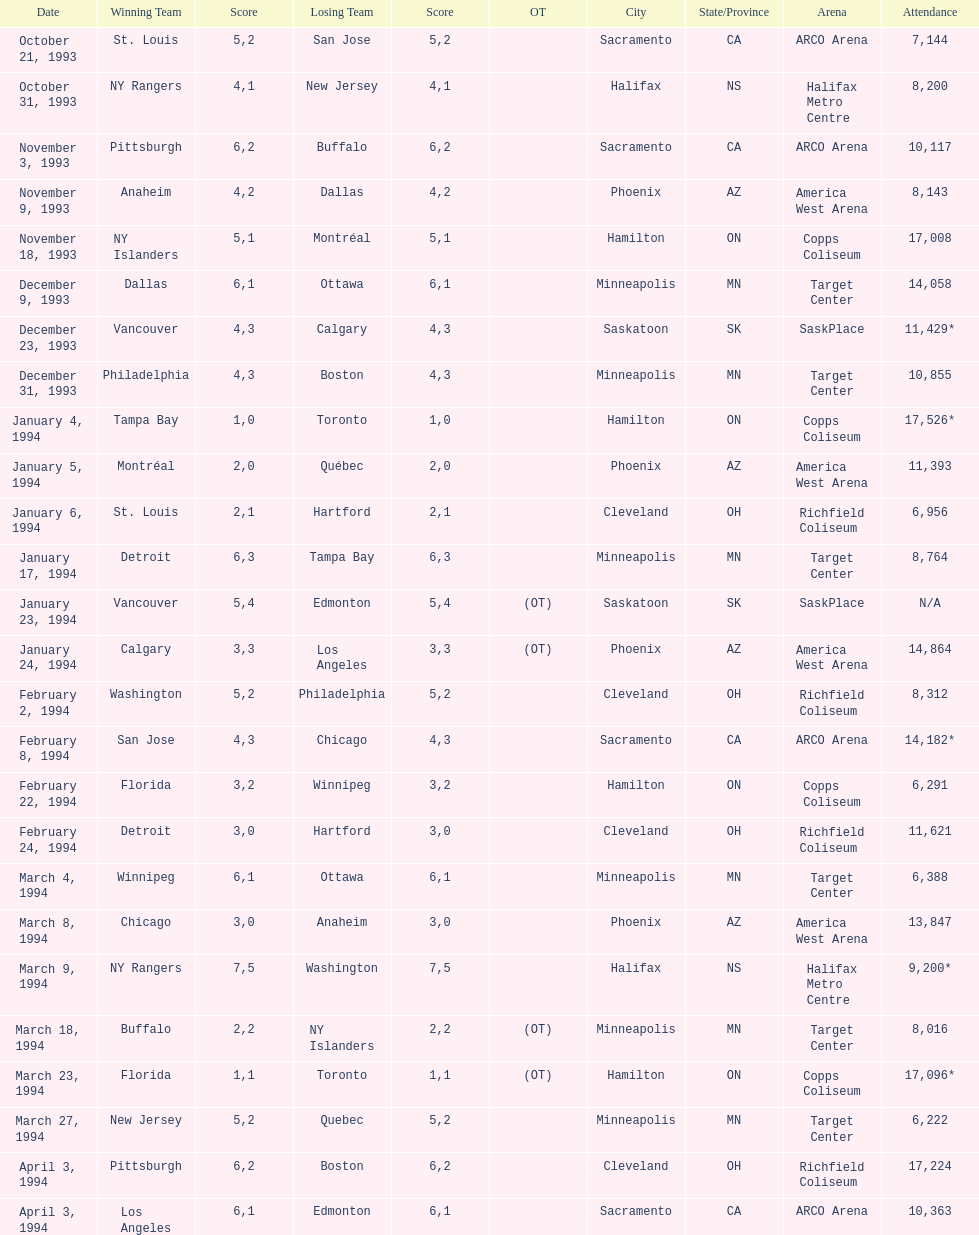Which event had higher attendance, january 24, 1994, or december 23, 1993? January 4, 1994. Parse the full table. {'header': ['Date', 'Winning Team', 'Score', 'Losing Team', 'Score', 'OT', 'City', 'State/Province', 'Arena', 'Attendance'], 'rows': [['October 21, 1993', 'St. Louis', '5', 'San Jose', '2', '', 'Sacramento', 'CA', 'ARCO Arena', '7,144'], ['October 31, 1993', 'NY Rangers', '4', 'New Jersey', '1', '', 'Halifax', 'NS', 'Halifax Metro Centre', '8,200'], ['November 3, 1993', 'Pittsburgh', '6', 'Buffalo', '2', '', 'Sacramento', 'CA', 'ARCO Arena', '10,117'], ['November 9, 1993', 'Anaheim', '4', 'Dallas', '2', '', 'Phoenix', 'AZ', 'America West Arena', '8,143'], ['November 18, 1993', 'NY Islanders', '5', 'Montréal', '1', '', 'Hamilton', 'ON', 'Copps Coliseum', '17,008'], ['December 9, 1993', 'Dallas', '6', 'Ottawa', '1', '', 'Minneapolis', 'MN', 'Target Center', '14,058'], ['December 23, 1993', 'Vancouver', '4', 'Calgary', '3', '', 'Saskatoon', 'SK', 'SaskPlace', '11,429*'], ['December 31, 1993', 'Philadelphia', '4', 'Boston', '3', '', 'Minneapolis', 'MN', 'Target Center', '10,855'], ['January 4, 1994', 'Tampa Bay', '1', 'Toronto', '0', '', 'Hamilton', 'ON', 'Copps Coliseum', '17,526*'], ['January 5, 1994', 'Montréal', '2', 'Québec', '0', '', 'Phoenix', 'AZ', 'America West Arena', '11,393'], ['January 6, 1994', 'St. Louis', '2', 'Hartford', '1', '', 'Cleveland', 'OH', 'Richfield Coliseum', '6,956'], ['January 17, 1994', 'Detroit', '6', 'Tampa Bay', '3', '', 'Minneapolis', 'MN', 'Target Center', '8,764'], ['January 23, 1994', 'Vancouver', '5', 'Edmonton', '4', '(OT)', 'Saskatoon', 'SK', 'SaskPlace', 'N/A'], ['January 24, 1994', 'Calgary', '3', 'Los Angeles', '3', '(OT)', 'Phoenix', 'AZ', 'America West Arena', '14,864'], ['February 2, 1994', 'Washington', '5', 'Philadelphia', '2', '', 'Cleveland', 'OH', 'Richfield Coliseum', '8,312'], ['February 8, 1994', 'San Jose', '4', 'Chicago', '3', '', 'Sacramento', 'CA', 'ARCO Arena', '14,182*'], ['February 22, 1994', 'Florida', '3', 'Winnipeg', '2', '', 'Hamilton', 'ON', 'Copps Coliseum', '6,291'], ['February 24, 1994', 'Detroit', '3', 'Hartford', '0', '', 'Cleveland', 'OH', 'Richfield Coliseum', '11,621'], ['March 4, 1994', 'Winnipeg', '6', 'Ottawa', '1', '', 'Minneapolis', 'MN', 'Target Center', '6,388'], ['March 8, 1994', 'Chicago', '3', 'Anaheim', '0', '', 'Phoenix', 'AZ', 'America West Arena', '13,847'], ['March 9, 1994', 'NY Rangers', '7', 'Washington', '5', '', 'Halifax', 'NS', 'Halifax Metro Centre', '9,200*'], ['March 18, 1994', 'Buffalo', '2', 'NY Islanders', '2', '(OT)', 'Minneapolis', 'MN', 'Target Center', '8,016'], ['March 23, 1994', 'Florida', '1', 'Toronto', '1', '(OT)', 'Hamilton', 'ON', 'Copps Coliseum', '17,096*'], ['March 27, 1994', 'New Jersey', '5', 'Quebec', '2', '', 'Minneapolis', 'MN', 'Target Center', '6,222'], ['April 3, 1994', 'Pittsburgh', '6', 'Boston', '2', '', 'Cleveland', 'OH', 'Richfield Coliseum', '17,224'], ['April 3, 1994', 'Los Angeles', '6', 'Edmonton', '1', '', 'Sacramento', 'CA', 'ARCO Arena', '10,363']]} 